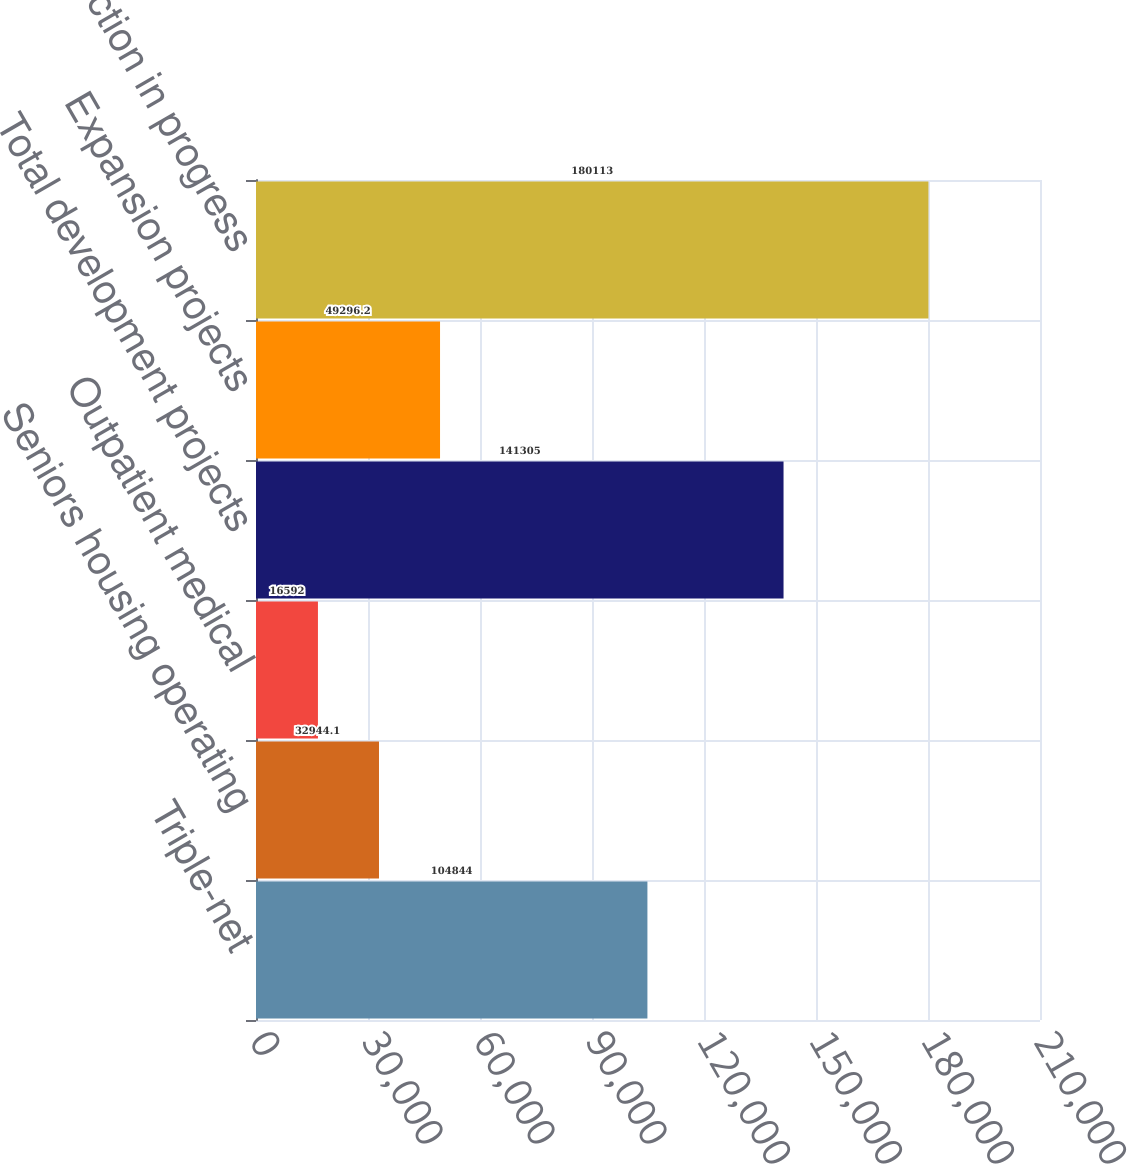Convert chart to OTSL. <chart><loc_0><loc_0><loc_500><loc_500><bar_chart><fcel>Triple-net<fcel>Seniors housing operating<fcel>Outpatient medical<fcel>Total development projects<fcel>Expansion projects<fcel>Total construction in progress<nl><fcel>104844<fcel>32944.1<fcel>16592<fcel>141305<fcel>49296.2<fcel>180113<nl></chart> 